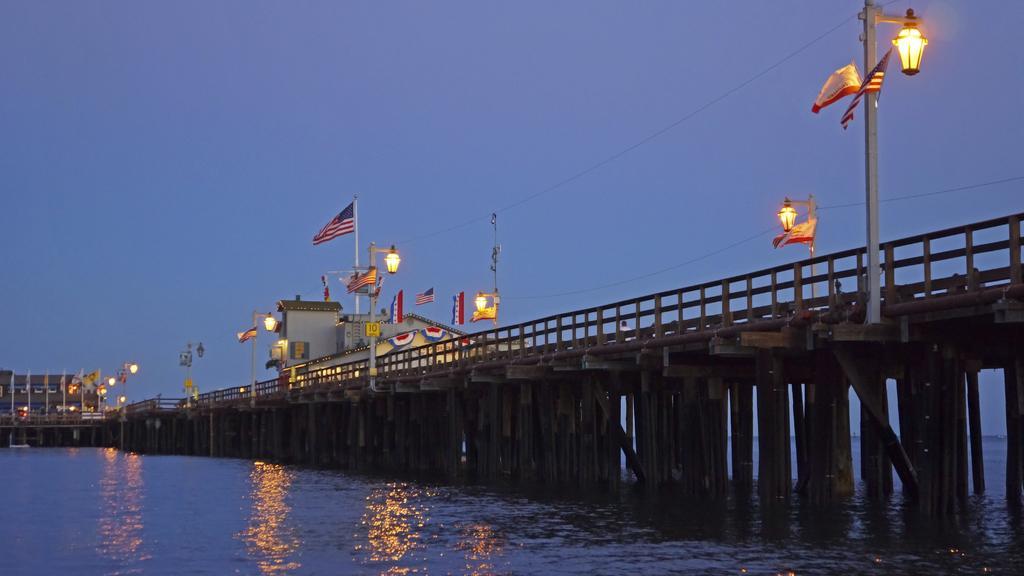Describe this image in one or two sentences. This image is taken outdoors. At the bottom of the image there is a sea. In the middle of the image there is a bridge with railings, pillars and iron bars. There are few poles with street lights and flags on the bridge. At the top of the image there is a sky. 